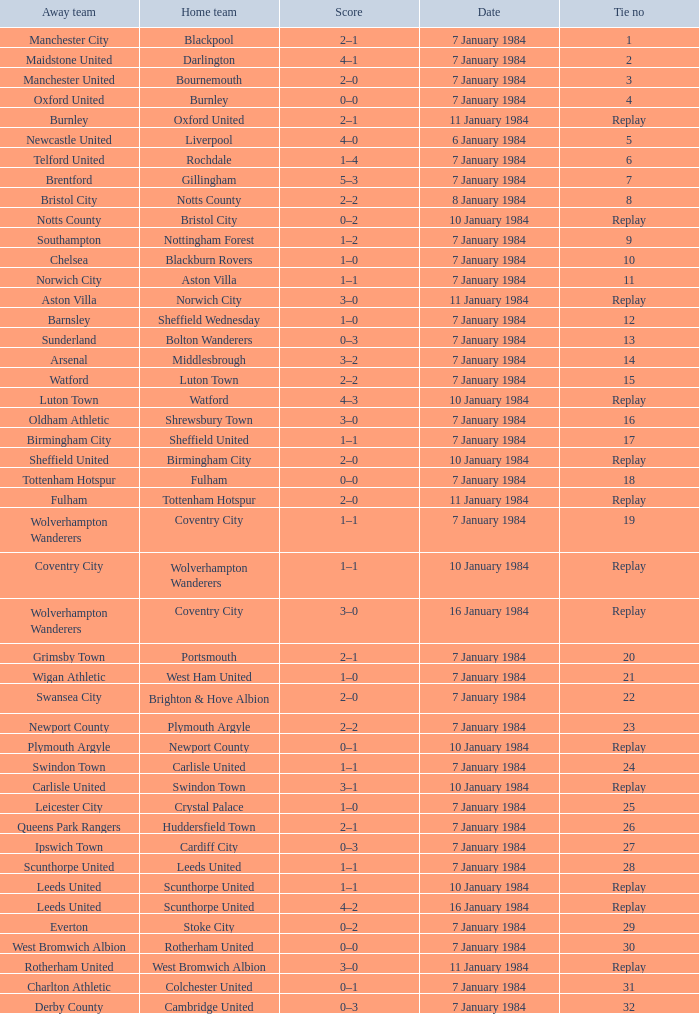Who was the away team with a tie of 14? Arsenal. 